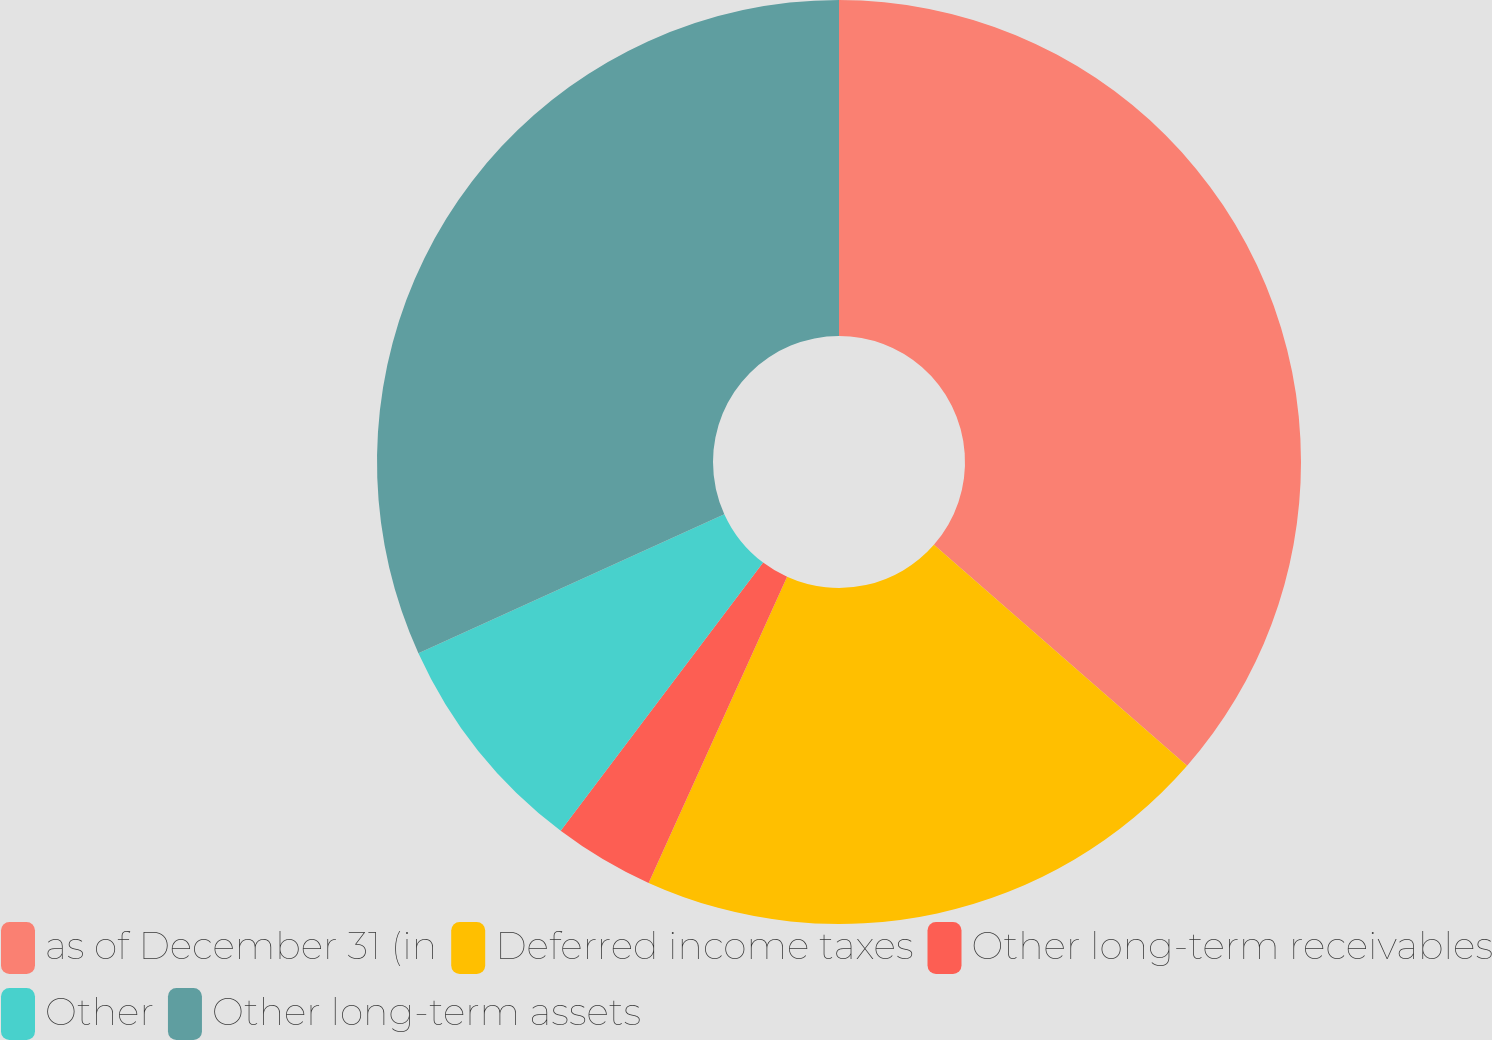<chart> <loc_0><loc_0><loc_500><loc_500><pie_chart><fcel>as of December 31 (in<fcel>Deferred income taxes<fcel>Other long-term receivables<fcel>Other<fcel>Other long-term assets<nl><fcel>36.42%<fcel>20.34%<fcel>3.53%<fcel>7.92%<fcel>31.79%<nl></chart> 